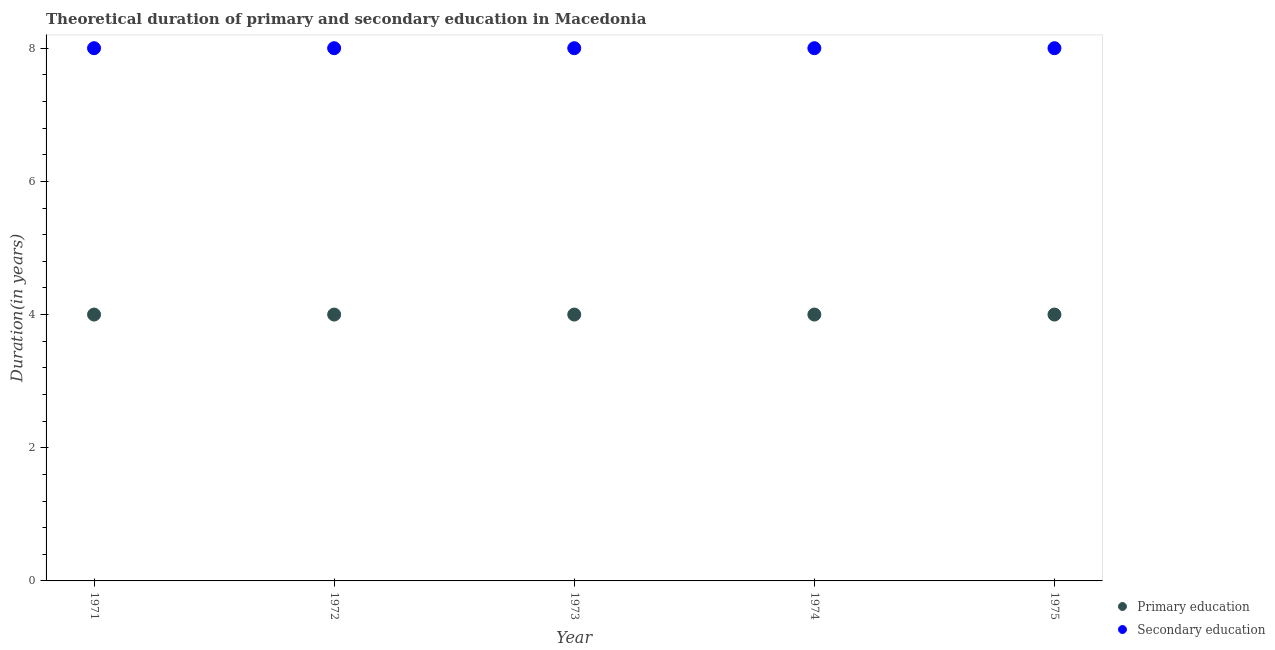How many different coloured dotlines are there?
Offer a terse response. 2. Is the number of dotlines equal to the number of legend labels?
Provide a succinct answer. Yes. What is the duration of primary education in 1972?
Offer a very short reply. 4. Across all years, what is the maximum duration of secondary education?
Offer a terse response. 8. Across all years, what is the minimum duration of secondary education?
Provide a short and direct response. 8. What is the total duration of primary education in the graph?
Your answer should be very brief. 20. What is the difference between the duration of secondary education in 1974 and the duration of primary education in 1973?
Offer a very short reply. 4. What is the average duration of primary education per year?
Your answer should be compact. 4. In the year 1972, what is the difference between the duration of secondary education and duration of primary education?
Give a very brief answer. 4. In how many years, is the duration of primary education greater than 2 years?
Your answer should be very brief. 5. Is the duration of secondary education in 1971 less than that in 1973?
Your answer should be compact. No. Is the difference between the duration of secondary education in 1971 and 1974 greater than the difference between the duration of primary education in 1971 and 1974?
Your answer should be compact. No. What is the difference between the highest and the lowest duration of primary education?
Keep it short and to the point. 0. In how many years, is the duration of secondary education greater than the average duration of secondary education taken over all years?
Make the answer very short. 0. Is the duration of secondary education strictly greater than the duration of primary education over the years?
Offer a very short reply. Yes. Is the duration of secondary education strictly less than the duration of primary education over the years?
Make the answer very short. No. How many dotlines are there?
Your answer should be compact. 2. How many years are there in the graph?
Your answer should be very brief. 5. Are the values on the major ticks of Y-axis written in scientific E-notation?
Make the answer very short. No. Where does the legend appear in the graph?
Provide a succinct answer. Bottom right. How many legend labels are there?
Give a very brief answer. 2. How are the legend labels stacked?
Provide a succinct answer. Vertical. What is the title of the graph?
Keep it short and to the point. Theoretical duration of primary and secondary education in Macedonia. What is the label or title of the Y-axis?
Your response must be concise. Duration(in years). What is the Duration(in years) in Primary education in 1971?
Provide a short and direct response. 4. What is the Duration(in years) of Secondary education in 1971?
Your response must be concise. 8. What is the Duration(in years) in Primary education in 1972?
Ensure brevity in your answer.  4. What is the Duration(in years) in Secondary education in 1973?
Your answer should be compact. 8. What is the Duration(in years) of Primary education in 1974?
Your answer should be very brief. 4. Across all years, what is the maximum Duration(in years) of Primary education?
Provide a short and direct response. 4. Across all years, what is the minimum Duration(in years) in Secondary education?
Provide a short and direct response. 8. What is the total Duration(in years) of Primary education in the graph?
Make the answer very short. 20. What is the difference between the Duration(in years) of Primary education in 1971 and that in 1973?
Provide a short and direct response. 0. What is the difference between the Duration(in years) of Primary education in 1972 and that in 1973?
Ensure brevity in your answer.  0. What is the difference between the Duration(in years) in Secondary education in 1972 and that in 1973?
Offer a very short reply. 0. What is the difference between the Duration(in years) of Secondary education in 1972 and that in 1974?
Your answer should be compact. 0. What is the difference between the Duration(in years) of Primary education in 1972 and that in 1975?
Offer a very short reply. 0. What is the difference between the Duration(in years) of Secondary education in 1973 and that in 1974?
Keep it short and to the point. 0. What is the difference between the Duration(in years) of Secondary education in 1973 and that in 1975?
Provide a short and direct response. 0. What is the difference between the Duration(in years) in Secondary education in 1974 and that in 1975?
Provide a succinct answer. 0. What is the difference between the Duration(in years) in Primary education in 1971 and the Duration(in years) in Secondary education in 1972?
Provide a short and direct response. -4. What is the difference between the Duration(in years) in Primary education in 1971 and the Duration(in years) in Secondary education in 1974?
Your answer should be compact. -4. What is the difference between the Duration(in years) in Primary education in 1971 and the Duration(in years) in Secondary education in 1975?
Keep it short and to the point. -4. What is the difference between the Duration(in years) of Primary education in 1972 and the Duration(in years) of Secondary education in 1974?
Make the answer very short. -4. What is the average Duration(in years) of Secondary education per year?
Offer a very short reply. 8. In the year 1972, what is the difference between the Duration(in years) of Primary education and Duration(in years) of Secondary education?
Provide a short and direct response. -4. What is the ratio of the Duration(in years) in Primary education in 1971 to that in 1972?
Offer a very short reply. 1. What is the ratio of the Duration(in years) in Primary education in 1971 to that in 1973?
Your answer should be compact. 1. What is the ratio of the Duration(in years) in Secondary education in 1971 to that in 1973?
Your response must be concise. 1. What is the ratio of the Duration(in years) of Secondary education in 1971 to that in 1975?
Your answer should be very brief. 1. What is the ratio of the Duration(in years) of Primary education in 1972 to that in 1973?
Offer a terse response. 1. What is the ratio of the Duration(in years) in Secondary education in 1972 to that in 1973?
Give a very brief answer. 1. What is the ratio of the Duration(in years) in Primary education in 1972 to that in 1974?
Your answer should be compact. 1. What is the ratio of the Duration(in years) of Primary education in 1973 to that in 1975?
Offer a terse response. 1. What is the ratio of the Duration(in years) in Secondary education in 1974 to that in 1975?
Offer a terse response. 1. What is the difference between the highest and the second highest Duration(in years) of Primary education?
Keep it short and to the point. 0. What is the difference between the highest and the lowest Duration(in years) in Secondary education?
Provide a short and direct response. 0. 